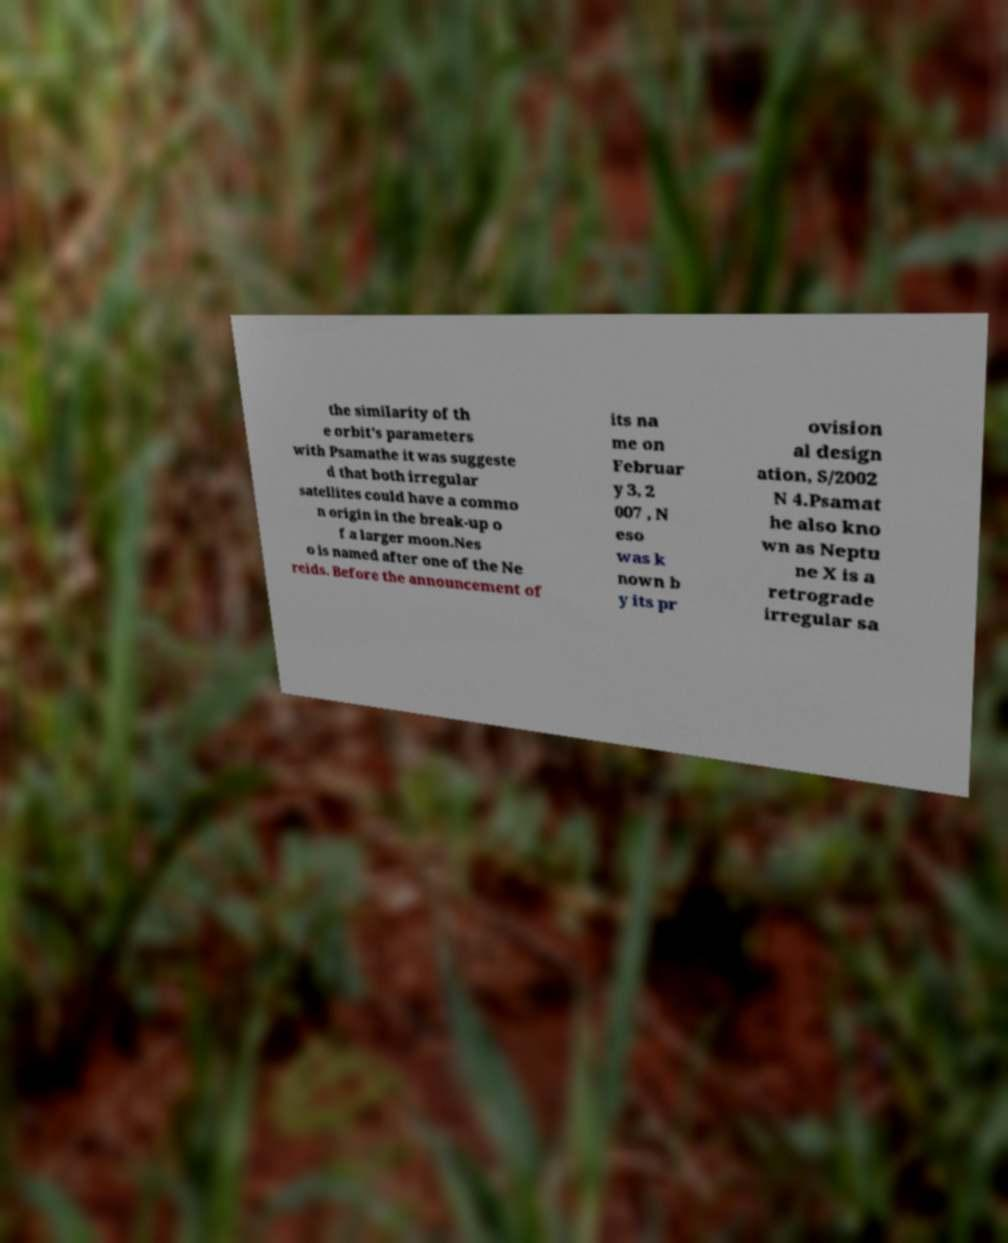Please read and relay the text visible in this image. What does it say? the similarity of th e orbit's parameters with Psamathe it was suggeste d that both irregular satellites could have a commo n origin in the break-up o f a larger moon.Nes o is named after one of the Ne reids. Before the announcement of its na me on Februar y 3, 2 007 , N eso was k nown b y its pr ovision al design ation, S/2002 N 4.Psamat he also kno wn as Neptu ne X is a retrograde irregular sa 